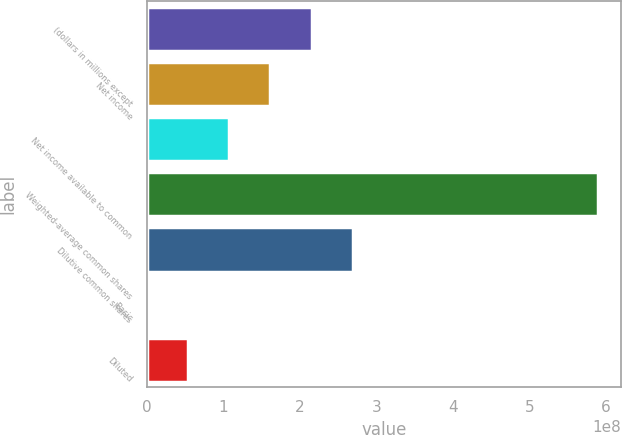Convert chart to OTSL. <chart><loc_0><loc_0><loc_500><loc_500><bar_chart><fcel>(dollars in millions except<fcel>Net income<fcel>Net income available to common<fcel>Weighted-average common shares<fcel>Dilutive common shares<fcel>Basic<fcel>Diluted<nl><fcel>2.15288e+08<fcel>1.61466e+08<fcel>1.07644e+08<fcel>5.89422e+08<fcel>2.6911e+08<fcel>1.55<fcel>5.38221e+07<nl></chart> 